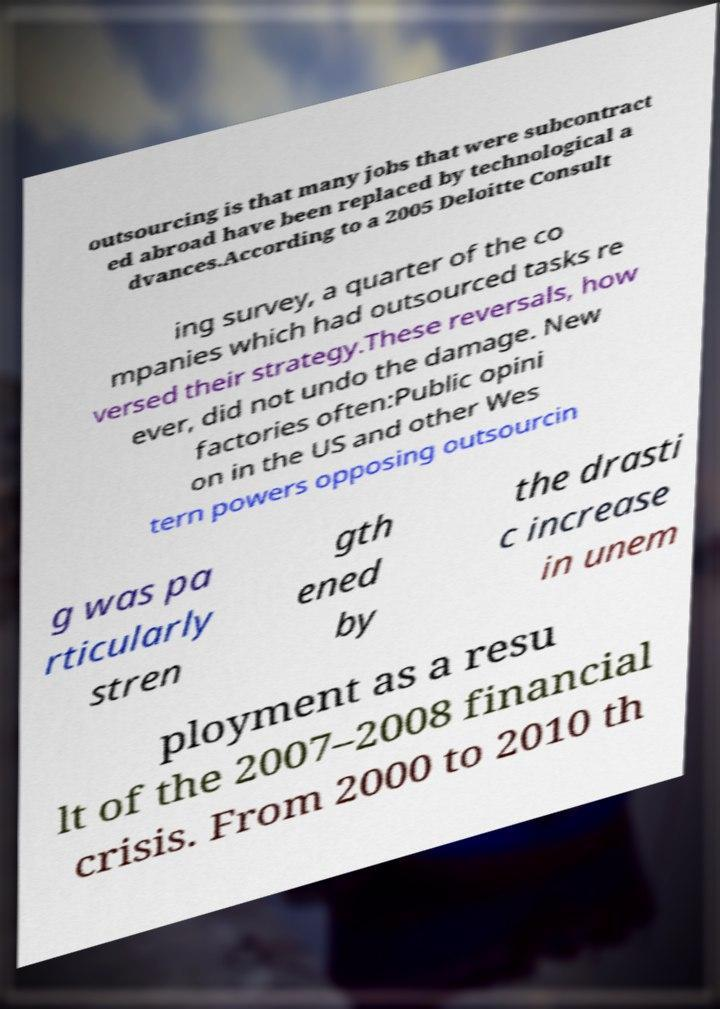Please read and relay the text visible in this image. What does it say? outsourcing is that many jobs that were subcontract ed abroad have been replaced by technological a dvances.According to a 2005 Deloitte Consult ing survey, a quarter of the co mpanies which had outsourced tasks re versed their strategy.These reversals, how ever, did not undo the damage. New factories often:Public opini on in the US and other Wes tern powers opposing outsourcin g was pa rticularly stren gth ened by the drasti c increase in unem ployment as a resu lt of the 2007–2008 financial crisis. From 2000 to 2010 th 